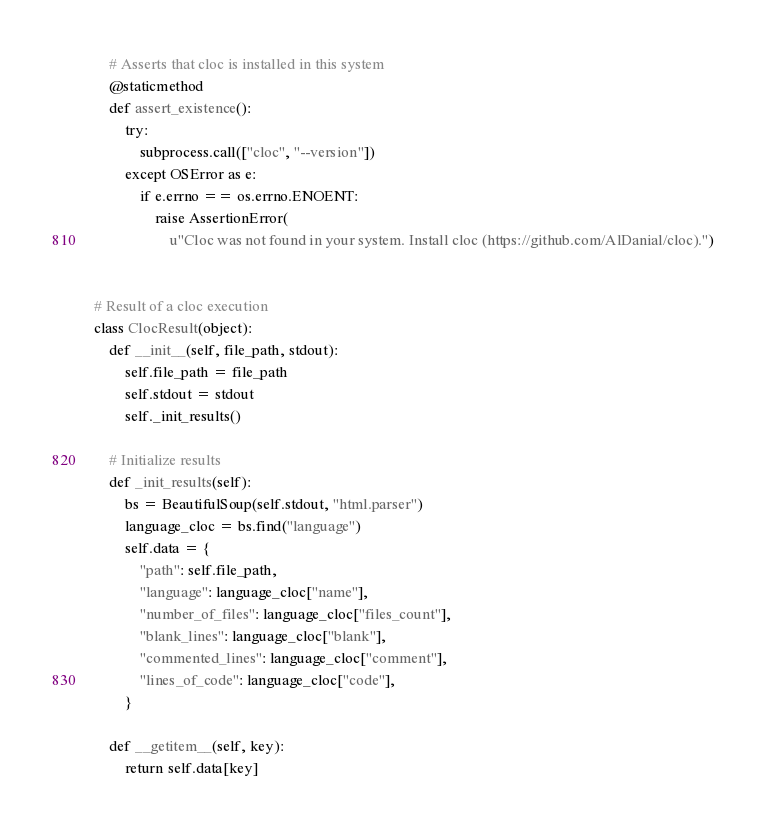<code> <loc_0><loc_0><loc_500><loc_500><_Python_>
    # Asserts that cloc is installed in this system
    @staticmethod
    def assert_existence():
        try:
            subprocess.call(["cloc", "--version"])
        except OSError as e:
            if e.errno == os.errno.ENOENT:
                raise AssertionError(
                    u"Cloc was not found in your system. Install cloc (https://github.com/AlDanial/cloc).")


# Result of a cloc execution
class ClocResult(object):
    def __init__(self, file_path, stdout):
        self.file_path = file_path
        self.stdout = stdout
        self._init_results()

    # Initialize results
    def _init_results(self):
        bs = BeautifulSoup(self.stdout, "html.parser")
        language_cloc = bs.find("language")
        self.data = {
            "path": self.file_path,
            "language": language_cloc["name"],
            "number_of_files": language_cloc["files_count"],
            "blank_lines": language_cloc["blank"],
            "commented_lines": language_cloc["comment"],
            "lines_of_code": language_cloc["code"],
        }

    def __getitem__(self, key):
        return self.data[key]

</code> 